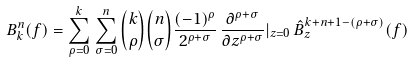<formula> <loc_0><loc_0><loc_500><loc_500>B ^ { n } _ { k } ( f ) = \sum _ { \rho = 0 } ^ { k } \, \sum _ { \sigma = 0 } ^ { n } \binom { k } { \rho } \binom { n } { \sigma } \frac { ( - 1 ) ^ { \rho } } { 2 ^ { \rho + \sigma } } \, \frac { \partial ^ { \rho + \sigma } } { \partial { z } ^ { \rho + \sigma } } | _ { z = 0 } \, \hat { B } ^ { k + n + 1 - ( \rho + \sigma ) } _ { z } ( f )</formula> 